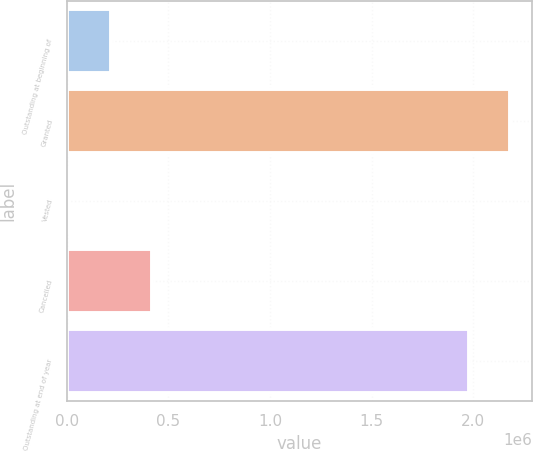Convert chart to OTSL. <chart><loc_0><loc_0><loc_500><loc_500><bar_chart><fcel>Outstanding at beginning of<fcel>Granted<fcel>Vested<fcel>Cancelled<fcel>Outstanding at end of year<nl><fcel>214689<fcel>2.18073e+06<fcel>12221<fcel>417157<fcel>1.97826e+06<nl></chart> 